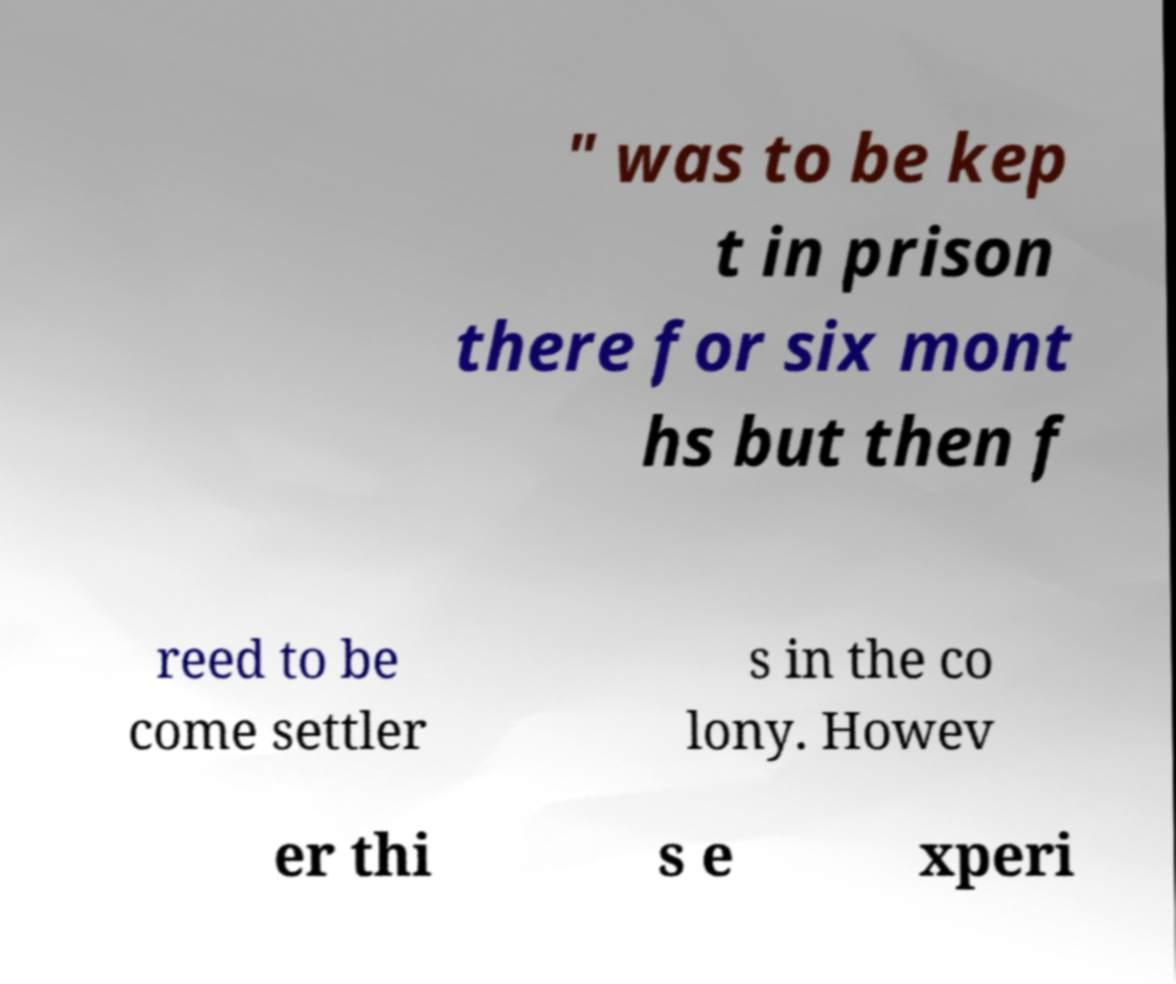I need the written content from this picture converted into text. Can you do that? " was to be kep t in prison there for six mont hs but then f reed to be come settler s in the co lony. Howev er thi s e xperi 